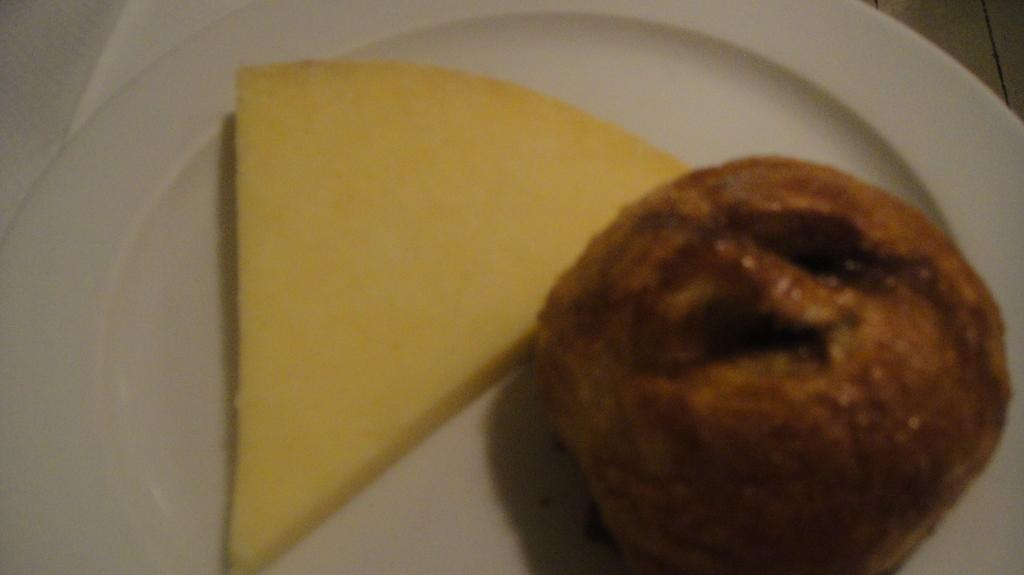What is the color of the platter in the image? The platter in the image is white. What is on the platter? The platter contains food items. Where is the platter located? The platter is placed on a table. How many legs does the sugar have in the image? There is no sugar present in the image, so it is not possible to determine how many legs it might have. 